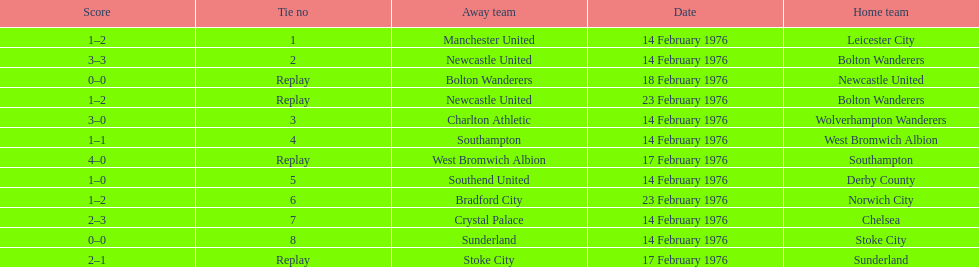How many of these games occurred before 17 february 1976? 7. 